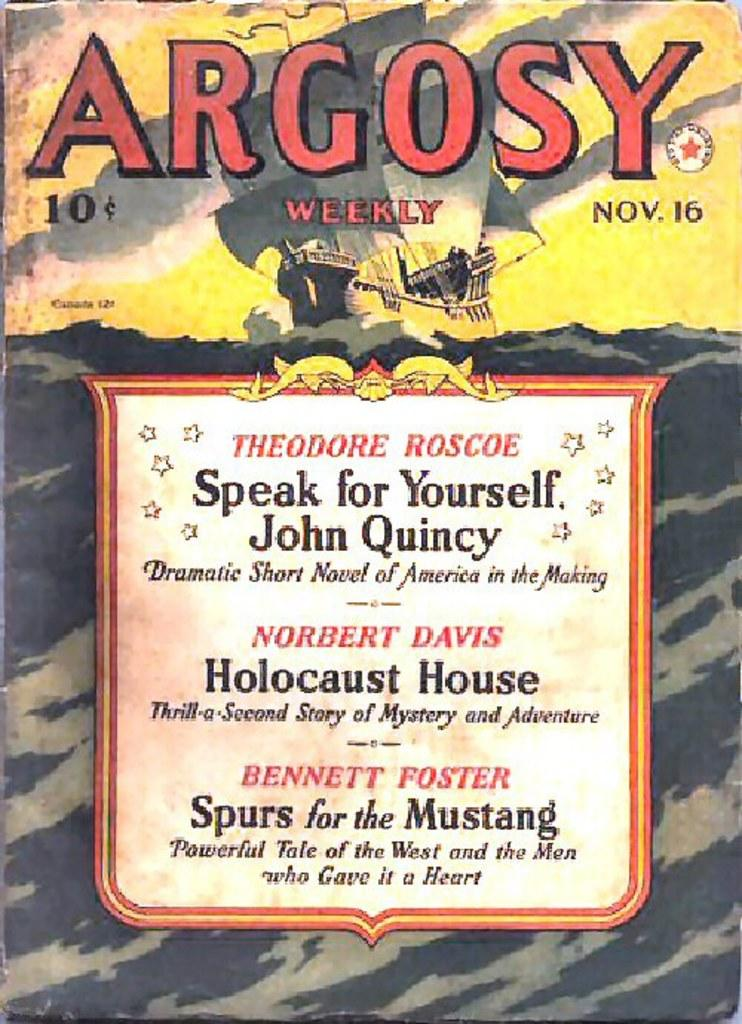What is the main subject of the image? The main subject of the image is a ship. Where is the ship located in the image? The ship is on water in the image. What is visible in the background of the image? The sky is visible in the image. Can you describe any text or writing on the ship? Yes, there is something written on the ship. Can you tell me how many men are working on the ship in the image? There is no information about men or laborers working on the ship in the image. Did the ship experience an earthquake while it was on water? There is no information about an earthquake or any other natural disaster in the image. 